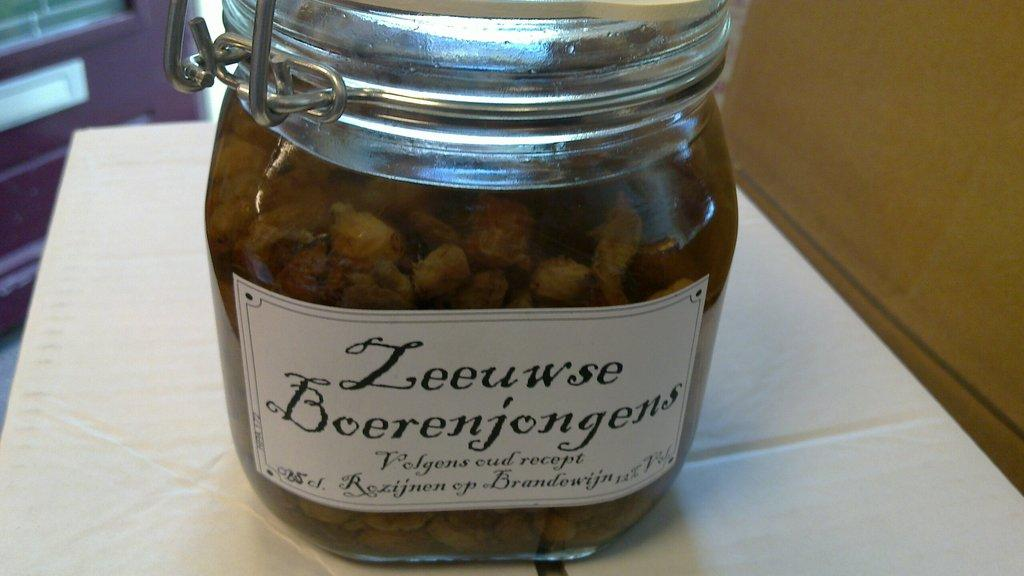<image>
Share a concise interpretation of the image provided. A glass jar of vegetables that says Leeuwse Boerenjongens. 